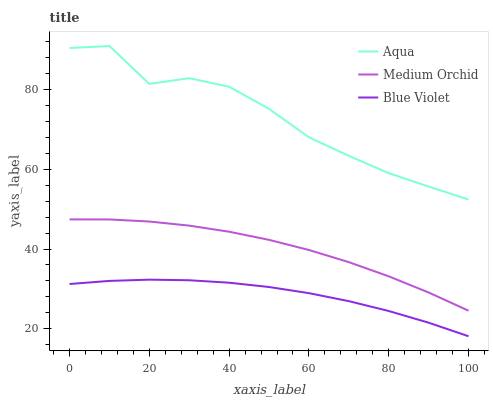Does Blue Violet have the minimum area under the curve?
Answer yes or no. Yes. Does Aqua have the maximum area under the curve?
Answer yes or no. Yes. Does Aqua have the minimum area under the curve?
Answer yes or no. No. Does Blue Violet have the maximum area under the curve?
Answer yes or no. No. Is Blue Violet the smoothest?
Answer yes or no. Yes. Is Aqua the roughest?
Answer yes or no. Yes. Is Aqua the smoothest?
Answer yes or no. No. Is Blue Violet the roughest?
Answer yes or no. No. Does Blue Violet have the lowest value?
Answer yes or no. Yes. Does Aqua have the lowest value?
Answer yes or no. No. Does Aqua have the highest value?
Answer yes or no. Yes. Does Blue Violet have the highest value?
Answer yes or no. No. Is Blue Violet less than Aqua?
Answer yes or no. Yes. Is Aqua greater than Blue Violet?
Answer yes or no. Yes. Does Blue Violet intersect Aqua?
Answer yes or no. No. 